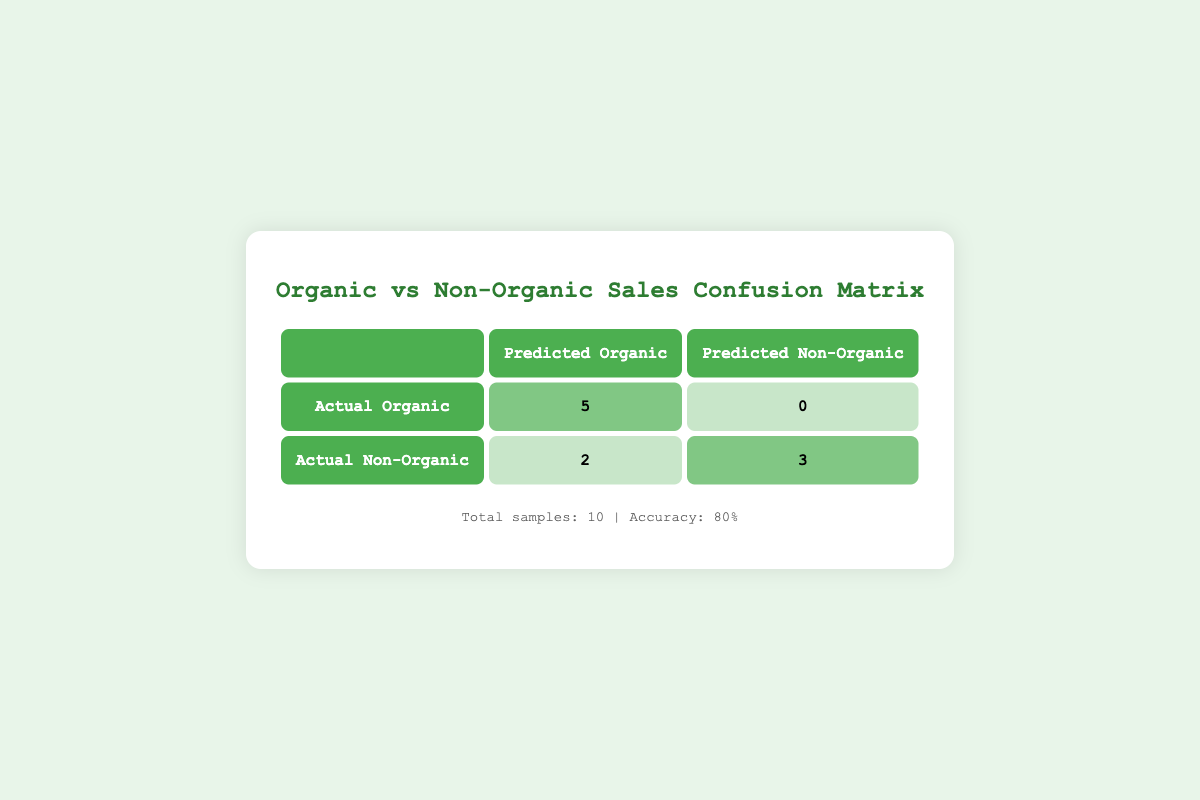What is the total number of successful sales for organic plants? From the table, we see that there are 5 successful sales for organic plants (highlighted in the matrix).
Answer: 5 What is the total number of successful sales for non-organic plants? In the table, the successful sales for non-organic plants amount to 3 (highlighted in the matrix).
Answer: 3 How many plants were predicted to be non-organic but were actually organic? The table shows that there were 0 predictions of non-organic plants that were actually organic, as indicated in the matrix.
Answer: 0 What is the accuracy of the sales predictions shown in the matrix? The accuracy is given as 80%, calculated as the number of correct predictions (5+3=8) divided by total samples (10).
Answer: 80% Is it true that all predicted organic sales were successful? Reviewing the table indicates that there were 2 predictions of organic sales that resulted in failures, meaning not all were successful.
Answer: No How many total samples are included in the sales data? The table summarizes the total samples as 10, combining both organic and non-organic sales recorded.
Answer: 10 What was the number of actual non-organic sales according to the matrix? According to the table, the number of actual non-organic sales is 5 (2 successful + 3 failed, which sum to 5 non-organic predictions).
Answer: 5 What is the difference in the number of successful sales between organic and non-organic plants? The difference is calculated as 5 successful organic sales minus 3 successful non-organic sales, which equals 2.
Answer: 2 If all successful sales were to increase by 50%, how many successful organic sales would that yield? Increasing the current 5 successful organic sales by 50% results in an additional 2.5 sales. Since we round down, it remains at 7 total successful organic sales.
Answer: 7 